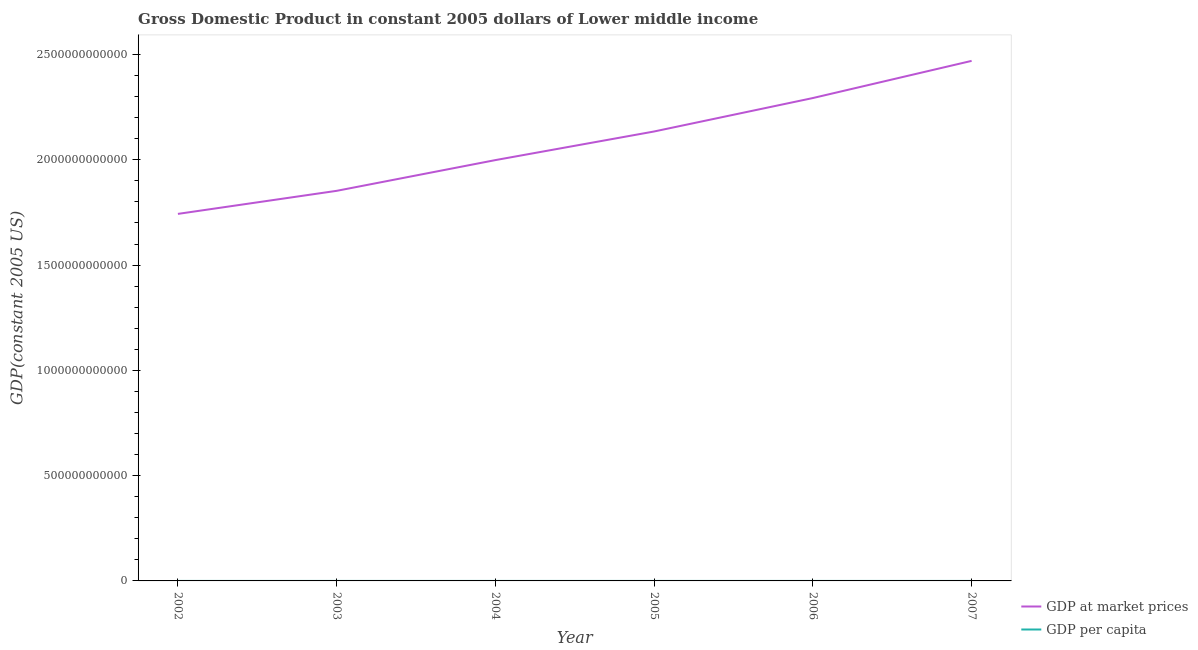How many different coloured lines are there?
Ensure brevity in your answer.  2. Does the line corresponding to gdp at market prices intersect with the line corresponding to gdp per capita?
Make the answer very short. No. Is the number of lines equal to the number of legend labels?
Your response must be concise. Yes. What is the gdp at market prices in 2005?
Your answer should be very brief. 2.13e+12. Across all years, what is the maximum gdp at market prices?
Give a very brief answer. 2.47e+12. Across all years, what is the minimum gdp per capita?
Give a very brief answer. 731.33. In which year was the gdp per capita minimum?
Offer a very short reply. 2002. What is the total gdp per capita in the graph?
Provide a short and direct response. 5014.66. What is the difference between the gdp at market prices in 2002 and that in 2004?
Make the answer very short. -2.56e+11. What is the difference between the gdp at market prices in 2002 and the gdp per capita in 2007?
Give a very brief answer. 1.74e+12. What is the average gdp per capita per year?
Provide a succinct answer. 835.78. In the year 2004, what is the difference between the gdp at market prices and gdp per capita?
Give a very brief answer. 2.00e+12. In how many years, is the gdp per capita greater than 1100000000000 US$?
Ensure brevity in your answer.  0. What is the ratio of the gdp per capita in 2004 to that in 2006?
Make the answer very short. 0.9. Is the difference between the gdp per capita in 2005 and 2006 greater than the difference between the gdp at market prices in 2005 and 2006?
Provide a short and direct response. Yes. What is the difference between the highest and the second highest gdp at market prices?
Provide a succinct answer. 1.76e+11. What is the difference between the highest and the lowest gdp at market prices?
Ensure brevity in your answer.  7.27e+11. Does the gdp at market prices monotonically increase over the years?
Offer a very short reply. Yes. Is the gdp per capita strictly less than the gdp at market prices over the years?
Give a very brief answer. Yes. What is the difference between two consecutive major ticks on the Y-axis?
Offer a terse response. 5.00e+11. Does the graph contain any zero values?
Give a very brief answer. No. Where does the legend appear in the graph?
Keep it short and to the point. Bottom right. How many legend labels are there?
Give a very brief answer. 2. How are the legend labels stacked?
Make the answer very short. Vertical. What is the title of the graph?
Provide a short and direct response. Gross Domestic Product in constant 2005 dollars of Lower middle income. Does "Rural Population" appear as one of the legend labels in the graph?
Provide a short and direct response. No. What is the label or title of the X-axis?
Offer a very short reply. Year. What is the label or title of the Y-axis?
Ensure brevity in your answer.  GDP(constant 2005 US). What is the GDP(constant 2005 US) of GDP at market prices in 2002?
Make the answer very short. 1.74e+12. What is the GDP(constant 2005 US) of GDP per capita in 2002?
Provide a succinct answer. 731.33. What is the GDP(constant 2005 US) of GDP at market prices in 2003?
Ensure brevity in your answer.  1.85e+12. What is the GDP(constant 2005 US) in GDP per capita in 2003?
Ensure brevity in your answer.  764.32. What is the GDP(constant 2005 US) in GDP at market prices in 2004?
Your answer should be very brief. 2.00e+12. What is the GDP(constant 2005 US) in GDP per capita in 2004?
Your response must be concise. 811.01. What is the GDP(constant 2005 US) in GDP at market prices in 2005?
Give a very brief answer. 2.13e+12. What is the GDP(constant 2005 US) of GDP per capita in 2005?
Keep it short and to the point. 852.13. What is the GDP(constant 2005 US) of GDP at market prices in 2006?
Your answer should be very brief. 2.29e+12. What is the GDP(constant 2005 US) in GDP per capita in 2006?
Offer a very short reply. 900.91. What is the GDP(constant 2005 US) in GDP at market prices in 2007?
Your answer should be very brief. 2.47e+12. What is the GDP(constant 2005 US) of GDP per capita in 2007?
Your response must be concise. 954.96. Across all years, what is the maximum GDP(constant 2005 US) of GDP at market prices?
Offer a terse response. 2.47e+12. Across all years, what is the maximum GDP(constant 2005 US) in GDP per capita?
Offer a very short reply. 954.96. Across all years, what is the minimum GDP(constant 2005 US) of GDP at market prices?
Ensure brevity in your answer.  1.74e+12. Across all years, what is the minimum GDP(constant 2005 US) in GDP per capita?
Give a very brief answer. 731.33. What is the total GDP(constant 2005 US) of GDP at market prices in the graph?
Keep it short and to the point. 1.25e+13. What is the total GDP(constant 2005 US) of GDP per capita in the graph?
Offer a terse response. 5014.66. What is the difference between the GDP(constant 2005 US) in GDP at market prices in 2002 and that in 2003?
Provide a short and direct response. -1.09e+11. What is the difference between the GDP(constant 2005 US) of GDP per capita in 2002 and that in 2003?
Offer a terse response. -32.99. What is the difference between the GDP(constant 2005 US) in GDP at market prices in 2002 and that in 2004?
Provide a short and direct response. -2.56e+11. What is the difference between the GDP(constant 2005 US) in GDP per capita in 2002 and that in 2004?
Offer a very short reply. -79.68. What is the difference between the GDP(constant 2005 US) of GDP at market prices in 2002 and that in 2005?
Make the answer very short. -3.91e+11. What is the difference between the GDP(constant 2005 US) in GDP per capita in 2002 and that in 2005?
Make the answer very short. -120.79. What is the difference between the GDP(constant 2005 US) in GDP at market prices in 2002 and that in 2006?
Provide a succinct answer. -5.50e+11. What is the difference between the GDP(constant 2005 US) in GDP per capita in 2002 and that in 2006?
Give a very brief answer. -169.57. What is the difference between the GDP(constant 2005 US) in GDP at market prices in 2002 and that in 2007?
Offer a very short reply. -7.27e+11. What is the difference between the GDP(constant 2005 US) of GDP per capita in 2002 and that in 2007?
Give a very brief answer. -223.62. What is the difference between the GDP(constant 2005 US) of GDP at market prices in 2003 and that in 2004?
Your answer should be very brief. -1.46e+11. What is the difference between the GDP(constant 2005 US) in GDP per capita in 2003 and that in 2004?
Give a very brief answer. -46.69. What is the difference between the GDP(constant 2005 US) in GDP at market prices in 2003 and that in 2005?
Keep it short and to the point. -2.82e+11. What is the difference between the GDP(constant 2005 US) of GDP per capita in 2003 and that in 2005?
Make the answer very short. -87.8. What is the difference between the GDP(constant 2005 US) of GDP at market prices in 2003 and that in 2006?
Ensure brevity in your answer.  -4.41e+11. What is the difference between the GDP(constant 2005 US) of GDP per capita in 2003 and that in 2006?
Ensure brevity in your answer.  -136.58. What is the difference between the GDP(constant 2005 US) of GDP at market prices in 2003 and that in 2007?
Provide a short and direct response. -6.17e+11. What is the difference between the GDP(constant 2005 US) in GDP per capita in 2003 and that in 2007?
Give a very brief answer. -190.63. What is the difference between the GDP(constant 2005 US) of GDP at market prices in 2004 and that in 2005?
Make the answer very short. -1.36e+11. What is the difference between the GDP(constant 2005 US) of GDP per capita in 2004 and that in 2005?
Offer a terse response. -41.11. What is the difference between the GDP(constant 2005 US) in GDP at market prices in 2004 and that in 2006?
Make the answer very short. -2.95e+11. What is the difference between the GDP(constant 2005 US) of GDP per capita in 2004 and that in 2006?
Ensure brevity in your answer.  -89.89. What is the difference between the GDP(constant 2005 US) in GDP at market prices in 2004 and that in 2007?
Ensure brevity in your answer.  -4.71e+11. What is the difference between the GDP(constant 2005 US) of GDP per capita in 2004 and that in 2007?
Provide a succinct answer. -143.94. What is the difference between the GDP(constant 2005 US) in GDP at market prices in 2005 and that in 2006?
Your response must be concise. -1.59e+11. What is the difference between the GDP(constant 2005 US) in GDP per capita in 2005 and that in 2006?
Give a very brief answer. -48.78. What is the difference between the GDP(constant 2005 US) of GDP at market prices in 2005 and that in 2007?
Your response must be concise. -3.35e+11. What is the difference between the GDP(constant 2005 US) in GDP per capita in 2005 and that in 2007?
Your answer should be very brief. -102.83. What is the difference between the GDP(constant 2005 US) of GDP at market prices in 2006 and that in 2007?
Provide a succinct answer. -1.76e+11. What is the difference between the GDP(constant 2005 US) of GDP per capita in 2006 and that in 2007?
Provide a succinct answer. -54.05. What is the difference between the GDP(constant 2005 US) of GDP at market prices in 2002 and the GDP(constant 2005 US) of GDP per capita in 2003?
Your answer should be compact. 1.74e+12. What is the difference between the GDP(constant 2005 US) of GDP at market prices in 2002 and the GDP(constant 2005 US) of GDP per capita in 2004?
Give a very brief answer. 1.74e+12. What is the difference between the GDP(constant 2005 US) in GDP at market prices in 2002 and the GDP(constant 2005 US) in GDP per capita in 2005?
Make the answer very short. 1.74e+12. What is the difference between the GDP(constant 2005 US) of GDP at market prices in 2002 and the GDP(constant 2005 US) of GDP per capita in 2006?
Ensure brevity in your answer.  1.74e+12. What is the difference between the GDP(constant 2005 US) in GDP at market prices in 2002 and the GDP(constant 2005 US) in GDP per capita in 2007?
Ensure brevity in your answer.  1.74e+12. What is the difference between the GDP(constant 2005 US) in GDP at market prices in 2003 and the GDP(constant 2005 US) in GDP per capita in 2004?
Your response must be concise. 1.85e+12. What is the difference between the GDP(constant 2005 US) of GDP at market prices in 2003 and the GDP(constant 2005 US) of GDP per capita in 2005?
Ensure brevity in your answer.  1.85e+12. What is the difference between the GDP(constant 2005 US) of GDP at market prices in 2003 and the GDP(constant 2005 US) of GDP per capita in 2006?
Offer a very short reply. 1.85e+12. What is the difference between the GDP(constant 2005 US) in GDP at market prices in 2003 and the GDP(constant 2005 US) in GDP per capita in 2007?
Ensure brevity in your answer.  1.85e+12. What is the difference between the GDP(constant 2005 US) of GDP at market prices in 2004 and the GDP(constant 2005 US) of GDP per capita in 2005?
Offer a very short reply. 2.00e+12. What is the difference between the GDP(constant 2005 US) of GDP at market prices in 2004 and the GDP(constant 2005 US) of GDP per capita in 2006?
Make the answer very short. 2.00e+12. What is the difference between the GDP(constant 2005 US) in GDP at market prices in 2004 and the GDP(constant 2005 US) in GDP per capita in 2007?
Keep it short and to the point. 2.00e+12. What is the difference between the GDP(constant 2005 US) of GDP at market prices in 2005 and the GDP(constant 2005 US) of GDP per capita in 2006?
Make the answer very short. 2.13e+12. What is the difference between the GDP(constant 2005 US) in GDP at market prices in 2005 and the GDP(constant 2005 US) in GDP per capita in 2007?
Offer a very short reply. 2.13e+12. What is the difference between the GDP(constant 2005 US) of GDP at market prices in 2006 and the GDP(constant 2005 US) of GDP per capita in 2007?
Make the answer very short. 2.29e+12. What is the average GDP(constant 2005 US) of GDP at market prices per year?
Give a very brief answer. 2.08e+12. What is the average GDP(constant 2005 US) in GDP per capita per year?
Ensure brevity in your answer.  835.78. In the year 2002, what is the difference between the GDP(constant 2005 US) in GDP at market prices and GDP(constant 2005 US) in GDP per capita?
Make the answer very short. 1.74e+12. In the year 2003, what is the difference between the GDP(constant 2005 US) of GDP at market prices and GDP(constant 2005 US) of GDP per capita?
Provide a succinct answer. 1.85e+12. In the year 2004, what is the difference between the GDP(constant 2005 US) in GDP at market prices and GDP(constant 2005 US) in GDP per capita?
Your response must be concise. 2.00e+12. In the year 2005, what is the difference between the GDP(constant 2005 US) of GDP at market prices and GDP(constant 2005 US) of GDP per capita?
Provide a short and direct response. 2.13e+12. In the year 2006, what is the difference between the GDP(constant 2005 US) in GDP at market prices and GDP(constant 2005 US) in GDP per capita?
Provide a short and direct response. 2.29e+12. In the year 2007, what is the difference between the GDP(constant 2005 US) in GDP at market prices and GDP(constant 2005 US) in GDP per capita?
Provide a short and direct response. 2.47e+12. What is the ratio of the GDP(constant 2005 US) of GDP at market prices in 2002 to that in 2003?
Offer a terse response. 0.94. What is the ratio of the GDP(constant 2005 US) of GDP per capita in 2002 to that in 2003?
Offer a very short reply. 0.96. What is the ratio of the GDP(constant 2005 US) of GDP at market prices in 2002 to that in 2004?
Offer a very short reply. 0.87. What is the ratio of the GDP(constant 2005 US) in GDP per capita in 2002 to that in 2004?
Your response must be concise. 0.9. What is the ratio of the GDP(constant 2005 US) of GDP at market prices in 2002 to that in 2005?
Provide a succinct answer. 0.82. What is the ratio of the GDP(constant 2005 US) in GDP per capita in 2002 to that in 2005?
Provide a short and direct response. 0.86. What is the ratio of the GDP(constant 2005 US) in GDP at market prices in 2002 to that in 2006?
Give a very brief answer. 0.76. What is the ratio of the GDP(constant 2005 US) of GDP per capita in 2002 to that in 2006?
Provide a succinct answer. 0.81. What is the ratio of the GDP(constant 2005 US) in GDP at market prices in 2002 to that in 2007?
Keep it short and to the point. 0.71. What is the ratio of the GDP(constant 2005 US) of GDP per capita in 2002 to that in 2007?
Provide a succinct answer. 0.77. What is the ratio of the GDP(constant 2005 US) of GDP at market prices in 2003 to that in 2004?
Offer a terse response. 0.93. What is the ratio of the GDP(constant 2005 US) in GDP per capita in 2003 to that in 2004?
Your response must be concise. 0.94. What is the ratio of the GDP(constant 2005 US) in GDP at market prices in 2003 to that in 2005?
Offer a very short reply. 0.87. What is the ratio of the GDP(constant 2005 US) in GDP per capita in 2003 to that in 2005?
Provide a succinct answer. 0.9. What is the ratio of the GDP(constant 2005 US) in GDP at market prices in 2003 to that in 2006?
Keep it short and to the point. 0.81. What is the ratio of the GDP(constant 2005 US) in GDP per capita in 2003 to that in 2006?
Ensure brevity in your answer.  0.85. What is the ratio of the GDP(constant 2005 US) of GDP at market prices in 2003 to that in 2007?
Your answer should be very brief. 0.75. What is the ratio of the GDP(constant 2005 US) of GDP per capita in 2003 to that in 2007?
Provide a short and direct response. 0.8. What is the ratio of the GDP(constant 2005 US) of GDP at market prices in 2004 to that in 2005?
Provide a succinct answer. 0.94. What is the ratio of the GDP(constant 2005 US) of GDP per capita in 2004 to that in 2005?
Offer a terse response. 0.95. What is the ratio of the GDP(constant 2005 US) in GDP at market prices in 2004 to that in 2006?
Provide a succinct answer. 0.87. What is the ratio of the GDP(constant 2005 US) in GDP per capita in 2004 to that in 2006?
Provide a short and direct response. 0.9. What is the ratio of the GDP(constant 2005 US) in GDP at market prices in 2004 to that in 2007?
Ensure brevity in your answer.  0.81. What is the ratio of the GDP(constant 2005 US) in GDP per capita in 2004 to that in 2007?
Your answer should be very brief. 0.85. What is the ratio of the GDP(constant 2005 US) in GDP at market prices in 2005 to that in 2006?
Make the answer very short. 0.93. What is the ratio of the GDP(constant 2005 US) in GDP per capita in 2005 to that in 2006?
Provide a succinct answer. 0.95. What is the ratio of the GDP(constant 2005 US) of GDP at market prices in 2005 to that in 2007?
Your answer should be compact. 0.86. What is the ratio of the GDP(constant 2005 US) in GDP per capita in 2005 to that in 2007?
Your response must be concise. 0.89. What is the ratio of the GDP(constant 2005 US) in GDP at market prices in 2006 to that in 2007?
Make the answer very short. 0.93. What is the ratio of the GDP(constant 2005 US) of GDP per capita in 2006 to that in 2007?
Your response must be concise. 0.94. What is the difference between the highest and the second highest GDP(constant 2005 US) of GDP at market prices?
Provide a succinct answer. 1.76e+11. What is the difference between the highest and the second highest GDP(constant 2005 US) of GDP per capita?
Your answer should be compact. 54.05. What is the difference between the highest and the lowest GDP(constant 2005 US) of GDP at market prices?
Offer a very short reply. 7.27e+11. What is the difference between the highest and the lowest GDP(constant 2005 US) of GDP per capita?
Your answer should be compact. 223.62. 